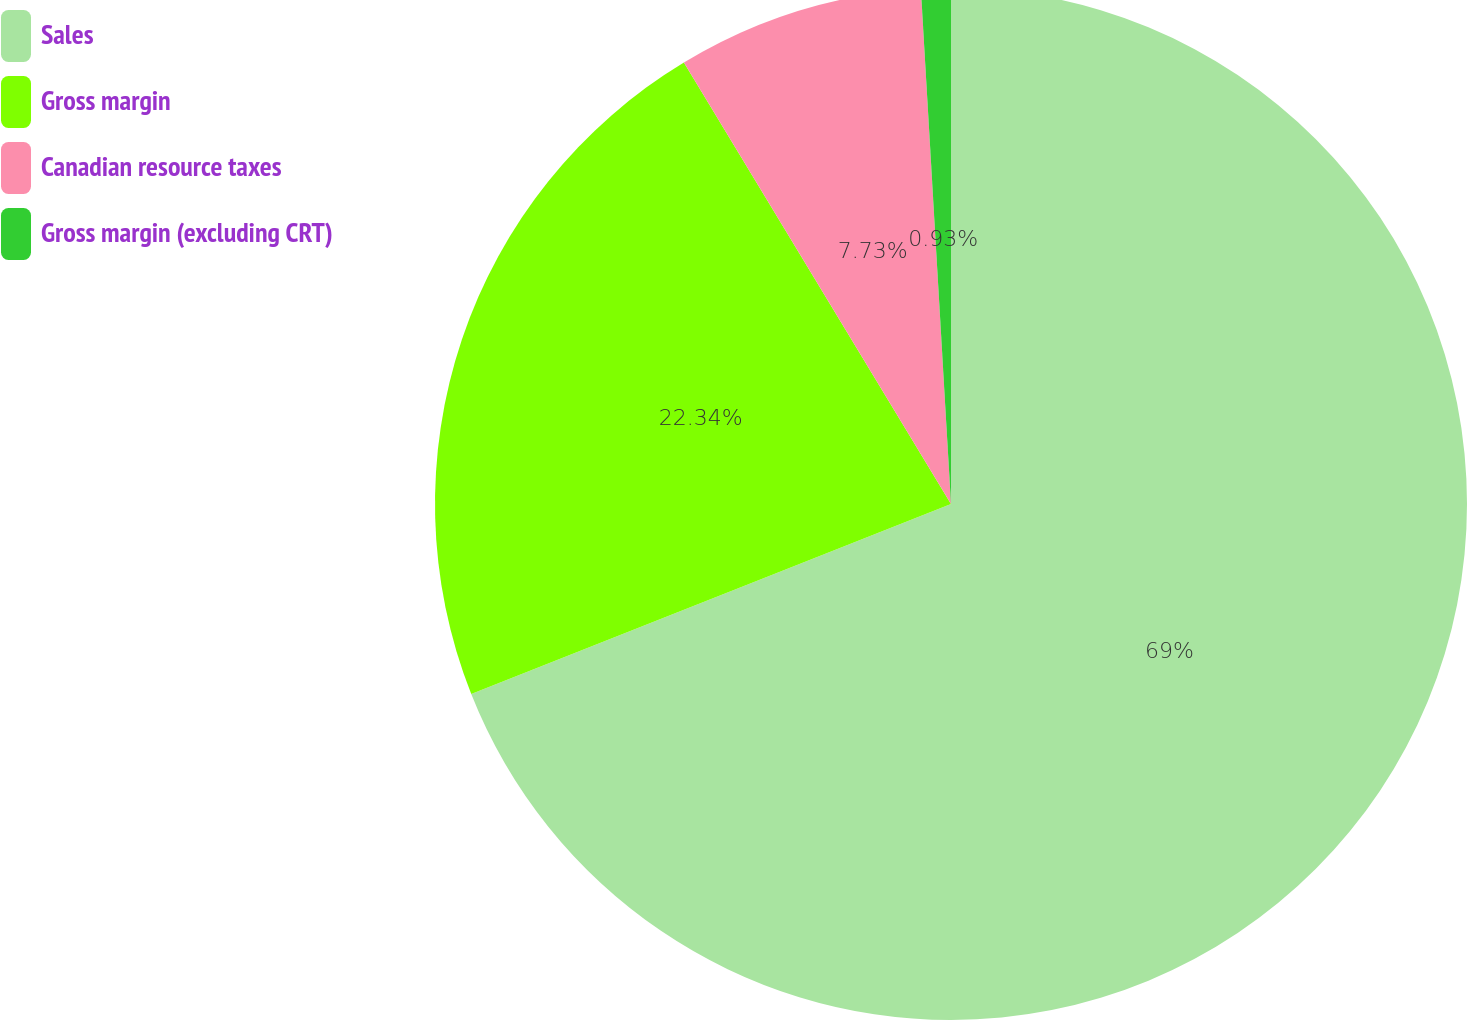Convert chart to OTSL. <chart><loc_0><loc_0><loc_500><loc_500><pie_chart><fcel>Sales<fcel>Gross margin<fcel>Canadian resource taxes<fcel>Gross margin (excluding CRT)<nl><fcel>69.0%<fcel>22.34%<fcel>7.73%<fcel>0.93%<nl></chart> 